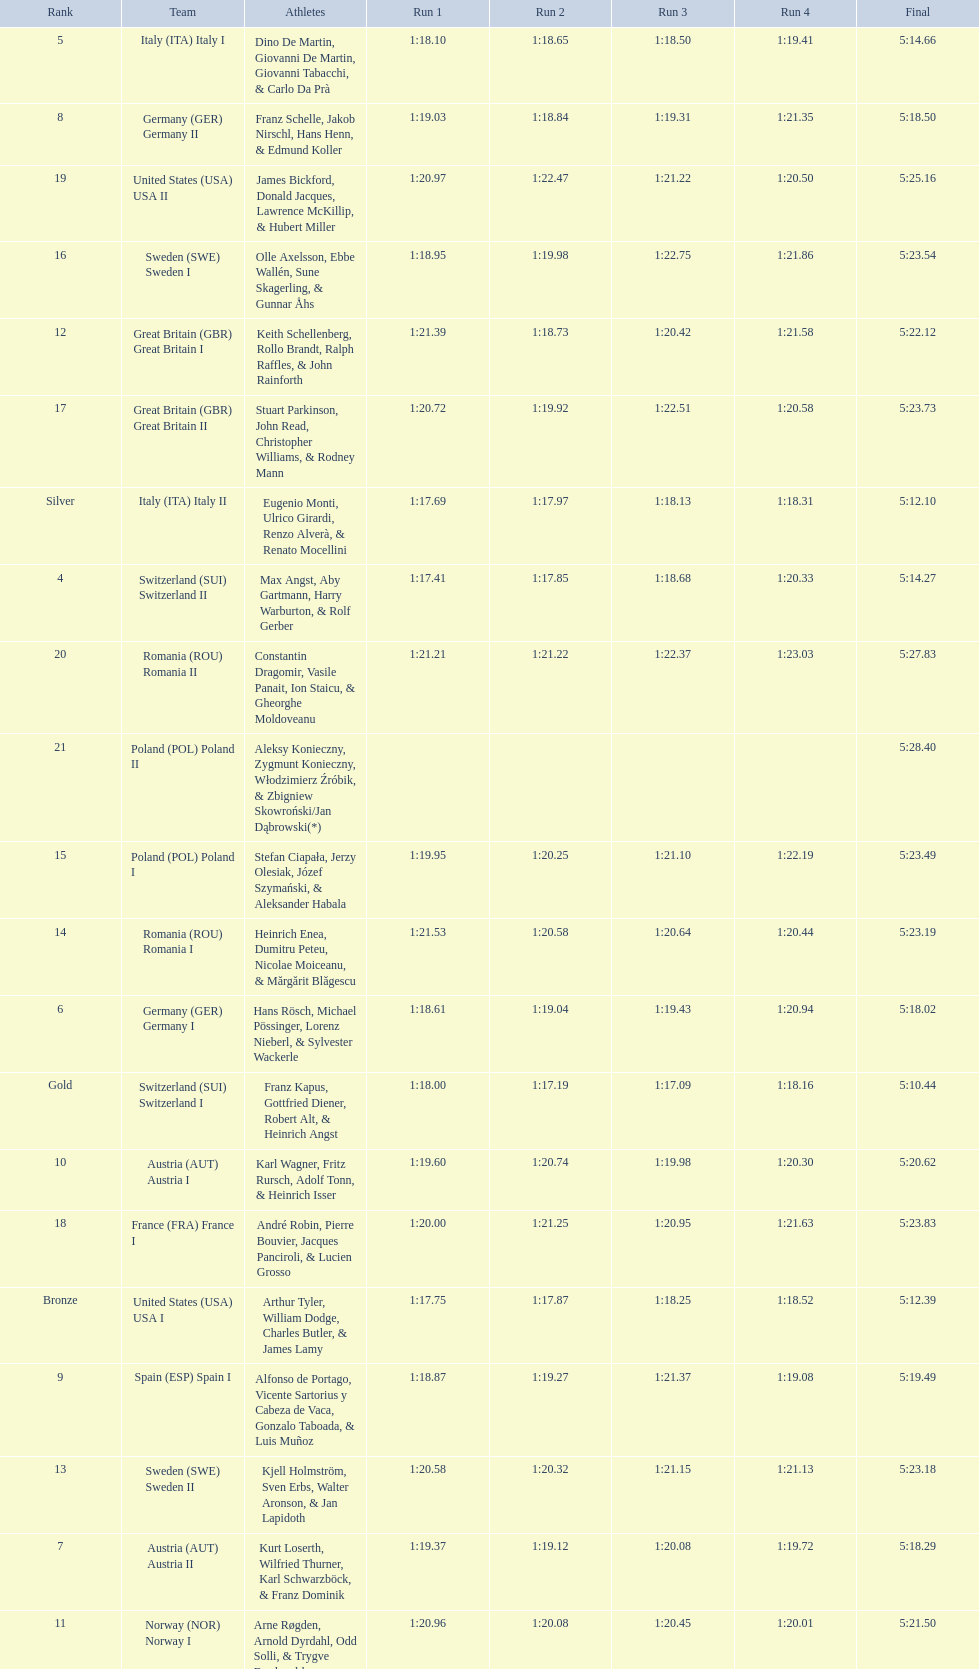What team came in second to last place? Romania. 